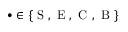<formula> <loc_0><loc_0><loc_500><loc_500>\bullet \in \{ S , E , C , B \}</formula> 